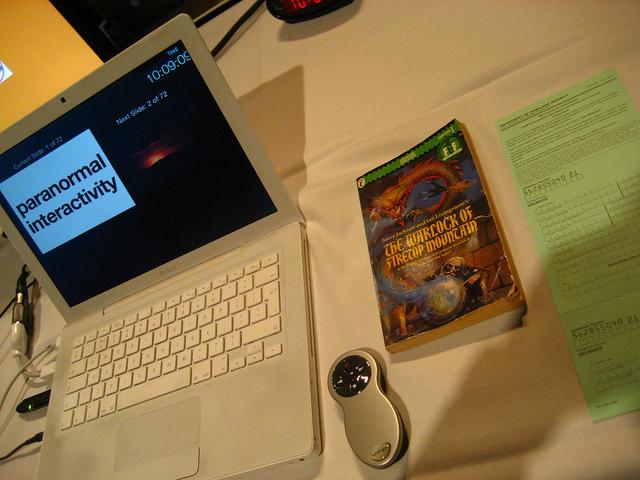Is this a laptop or a desktop?
Short answer required. Laptop. How many remotes are seen?
Give a very brief answer. 1. What shape is the phone?
Answer briefly. Oval. Is there a cd seen?
Be succinct. No. How many batteries do you see?
Write a very short answer. 0. How many computers are there?
Answer briefly. 1. What words are on the computer screen?
Write a very short answer. Paranormal interactivity. What time is it?
Short answer required. 10:09. What is this machine?
Short answer required. Laptop. How many books are in the picture?
Give a very brief answer. 1. What type of laptop is that?
Quick response, please. Macbook. Is this an old book?
Quick response, please. Yes. Is the laptop hooked to a TV monitor?
Be succinct. No. What is the remote for?
Concise answer only. Tv. What is the book title?
Concise answer only. Warlock of firetop mountain. Are there books on this table?
Short answer required. Yes. 